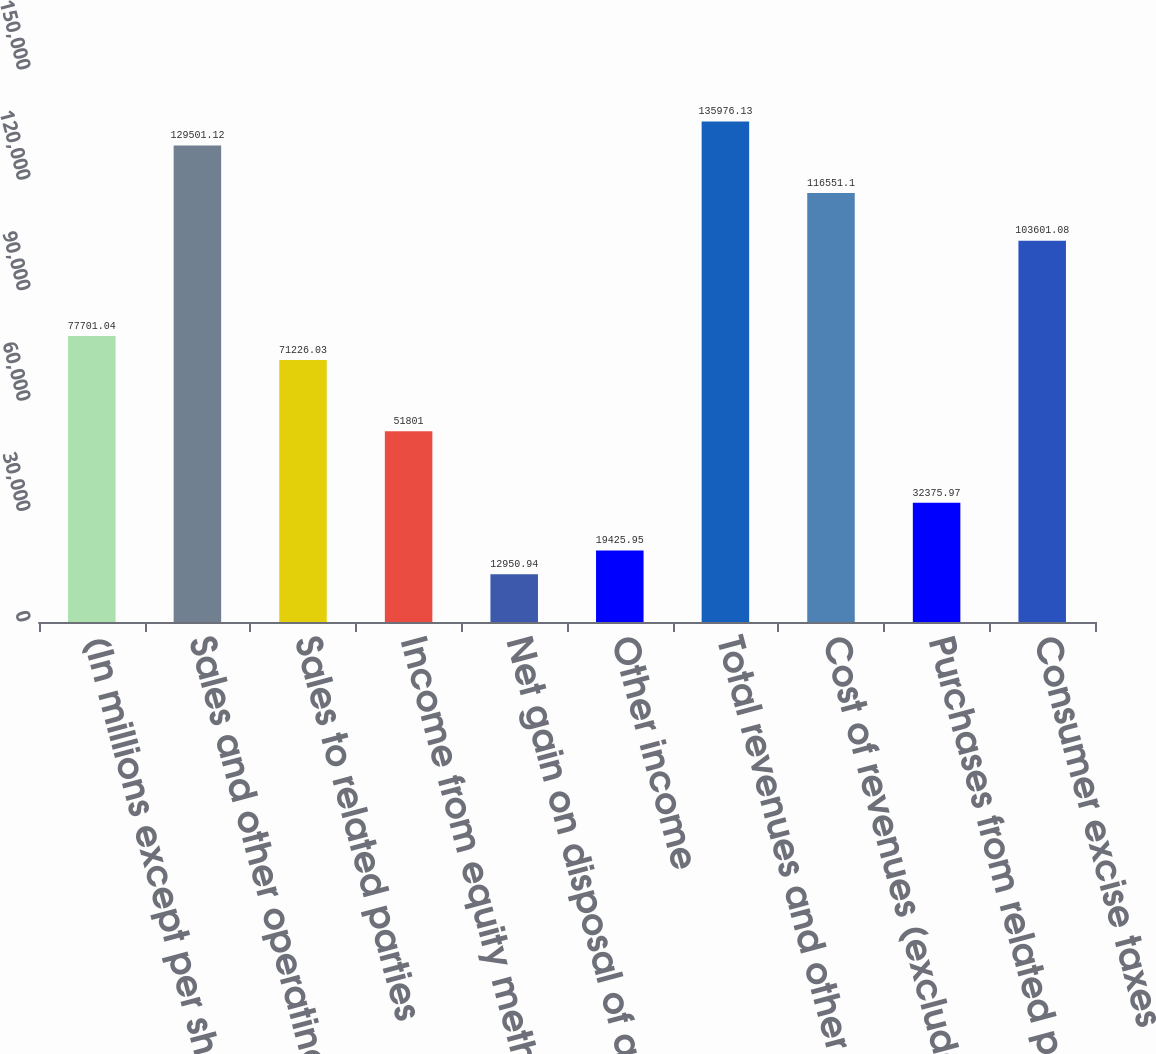Convert chart. <chart><loc_0><loc_0><loc_500><loc_500><bar_chart><fcel>(In millions except per share<fcel>Sales and other operating<fcel>Sales to related parties<fcel>Income from equity method<fcel>Net gain on disposal of assets<fcel>Other income<fcel>Total revenues and other<fcel>Cost of revenues (excludes<fcel>Purchases from related parties<fcel>Consumer excise taxes<nl><fcel>77701<fcel>129501<fcel>71226<fcel>51801<fcel>12950.9<fcel>19426<fcel>135976<fcel>116551<fcel>32376<fcel>103601<nl></chart> 